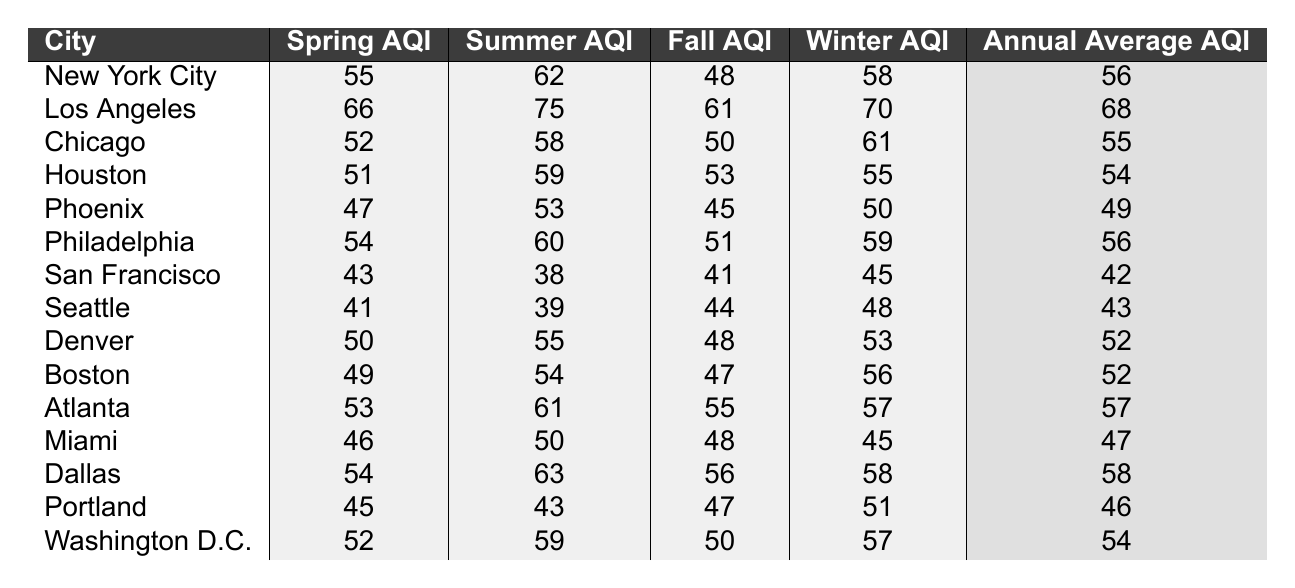What is the AQI for Miami during the summer? The table shows that Miami's summer AQI is 50.
Answer: 50 Which city has the highest annual average AQI? By examining the "Annual Average AQI" row, Los Angeles has the highest value at 68.
Answer: Los Angeles True or False: The Fall AQI in San Francisco is higher than in Seattle. San Francisco's Fall AQI is 41, while Seattle's is 44. Since 41 is less than 44, the statement is false.
Answer: False What is the difference between the Spring AQI of New York City and Chicago? New York City has a Spring AQI of 55, and Chicago has 52. The difference is 55 - 52 = 3.
Answer: 3 Which city has the lowest Winter AQI and what is that value? Looking through the Winter AQI data, San Francisco has the lowest value at 45.
Answer: San Francisco, 45 What is the average Summer AQI for the cities listed? To find the average, sum the Summer AQIs: (62 + 75 + 58 + 59 + 53 + 60 + 38 + 39 + 55 + 54 + 61 + 50 + 63 + 43 + 59) = 829. There are 15 cities, so the average is 829 / 15 ≈ 55.27.
Answer: 55.27 Which season generally has the highest AQI across all cities? Analyzing the values for each season, Summer AQI values are generally higher compared to Spring, Fall, and Winter.
Answer: Summer Is the Annual Average AQI for Boston greater than that for Houston? Boston's Annual Average AQI is 52, while Houston's is 54. Since 52 is less than 54, the statement is false.
Answer: False What is the total AQI for all seasons in Atlanta? Atlanta's AQIs are: Spring 53, Summer 61, Fall 55, Winter 57. The total is 53 + 61 + 55 + 57 = 226.
Answer: 226 Which city shows a consistent decrease from Spring to Summer AQI? Inspecting the Spring and Summer AQIs, San Francisco shows a decrease from 43 (Spring) to 38 (Summer).
Answer: San Francisco 